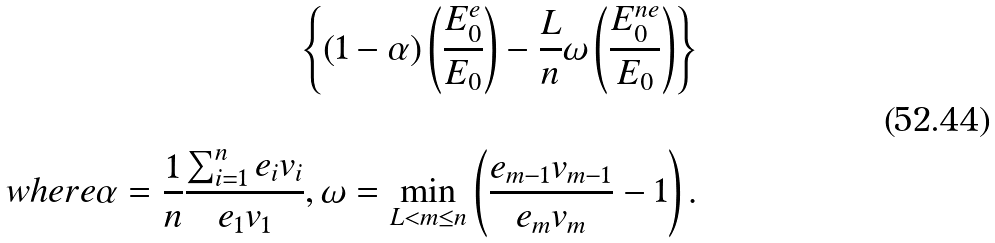<formula> <loc_0><loc_0><loc_500><loc_500>\left \{ ( 1 - \alpha ) \left ( \frac { E _ { 0 } ^ { e } } { E _ { 0 } } \right ) - \frac { L } { n } \omega \left ( \frac { E _ { 0 } ^ { n e } } { E _ { 0 } } \right ) \right \} \\ \\ w h e r e \alpha = \frac { 1 } { n } \frac { \sum _ { i = 1 } ^ { n } e _ { i } v _ { i } } { e _ { 1 } v _ { 1 } } , \omega = \min _ { L < m \leq n } \left ( \frac { e _ { m - 1 } v _ { m - 1 } } { e _ { m } v _ { m } } - 1 \right ) .</formula> 